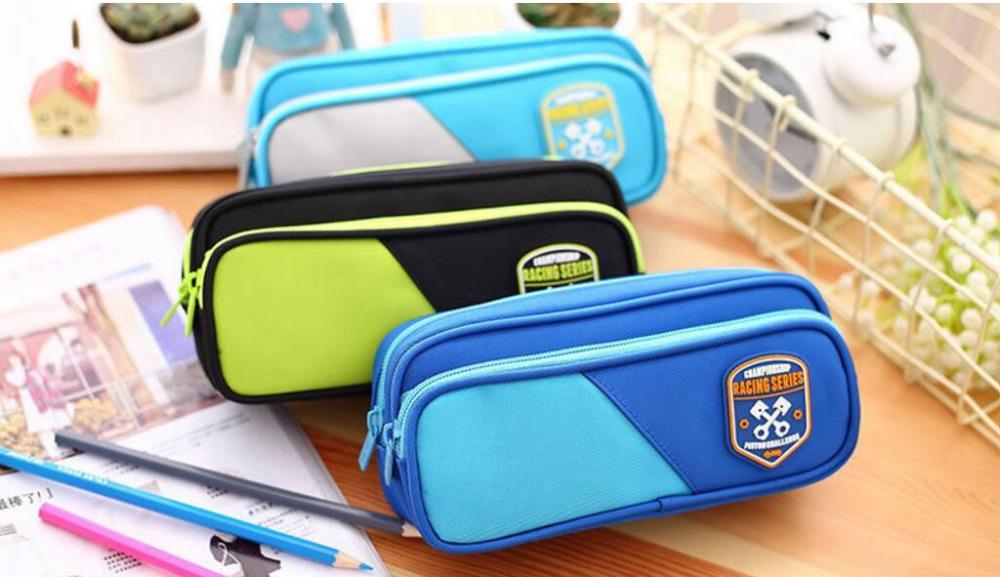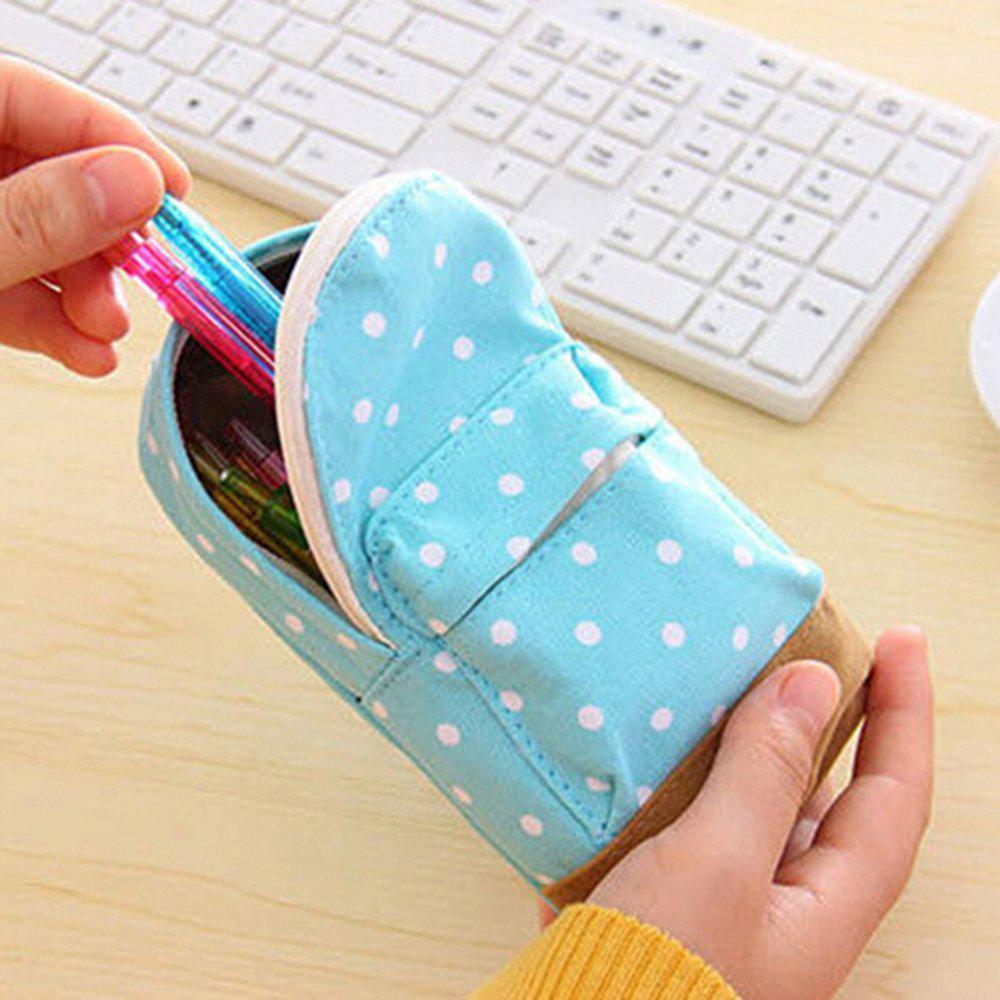The first image is the image on the left, the second image is the image on the right. For the images displayed, is the sentence "At least one of the cases is closed." factually correct? Answer yes or no. Yes. The first image is the image on the left, the second image is the image on the right. Analyze the images presented: Is the assertion "Each image only contains one showcased item" valid? Answer yes or no. No. 